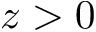<formula> <loc_0><loc_0><loc_500><loc_500>z > 0</formula> 